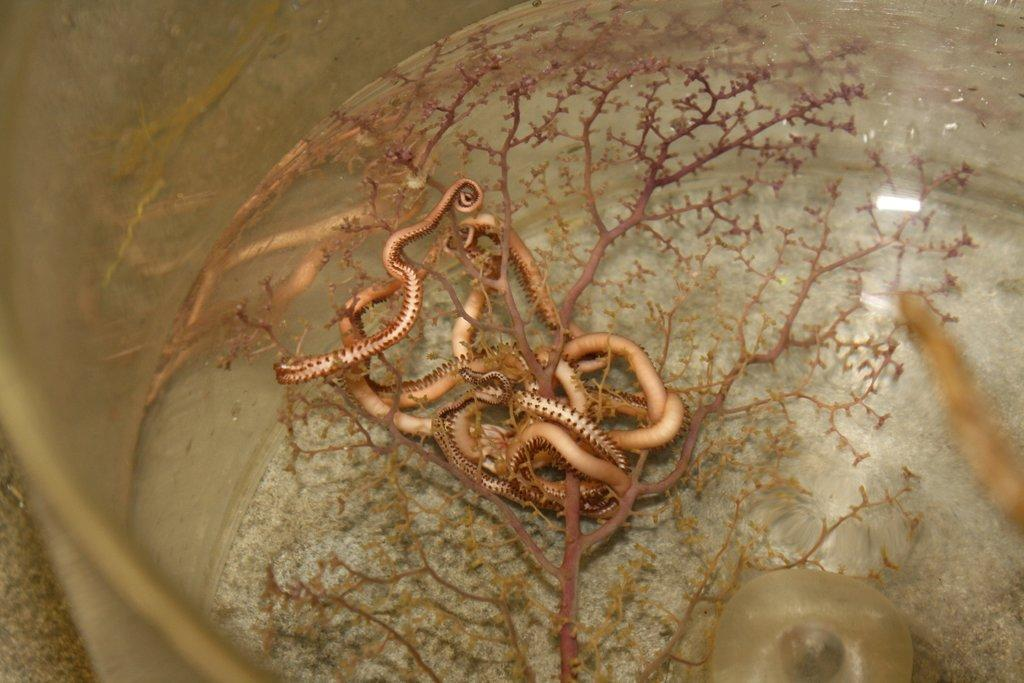What is in the container that is visible in the image? The container holds water. What else can be seen in the container besides water? There are flowers, specifically warms, and stems in the container. Where is the container located in the image? The container is placed on a surface. Is the queen present in the image, sitting on her throne? There is no queen or throne present in the image; it features a container with water, warms, and stems. 